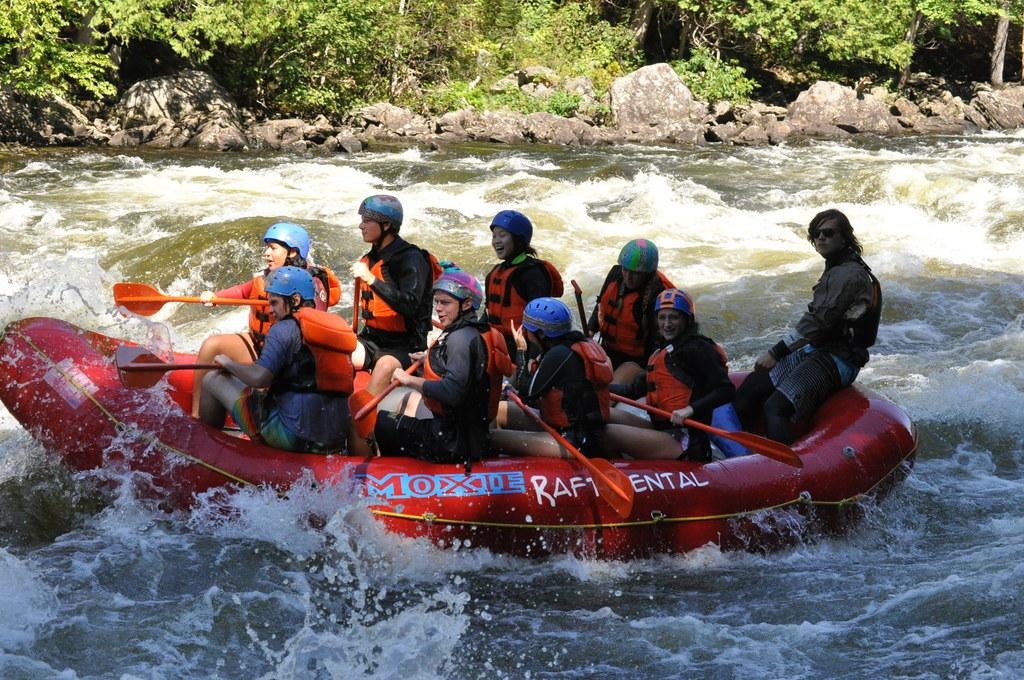What is in the foreground of the image? There is a water body in the foreground of the image. What are the people in the boat doing? The people are in a boat doing rafting in the middle of the water. What can be seen at the top of the image? There are trees and rocks at the top of the image. Where is the lunchroom located in the image? There is no lunchroom present in the image. How many balls can be seen in the image? There are no balls visible in the image. 